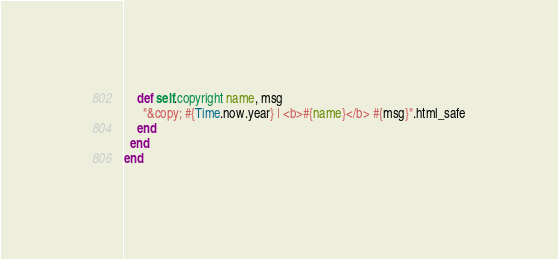Convert code to text. <code><loc_0><loc_0><loc_500><loc_500><_Ruby_>    def self.copyright name, msg
      "&copy; #{Time.now.year} | <b>#{name}</b> #{msg}".html_safe
    end
  end
end
</code> 